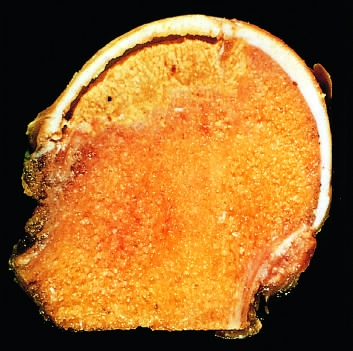what is caused by trabecular compression fractures without repair?
Answer the question using a single word or phrase. The space between the overlying articular cartilage and bone 